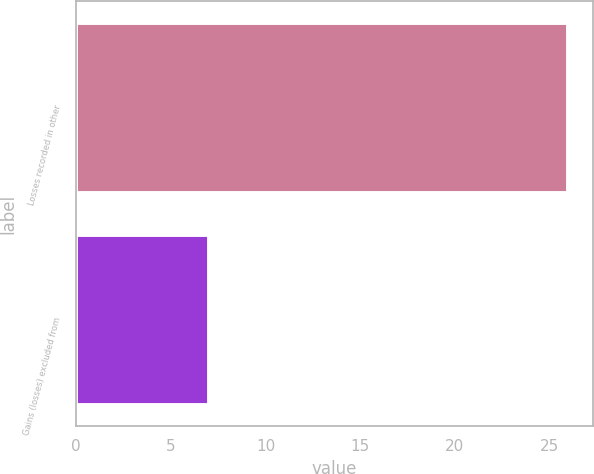Convert chart to OTSL. <chart><loc_0><loc_0><loc_500><loc_500><bar_chart><fcel>Losses recorded in other<fcel>Gains (losses) excluded from<nl><fcel>26<fcel>7<nl></chart> 